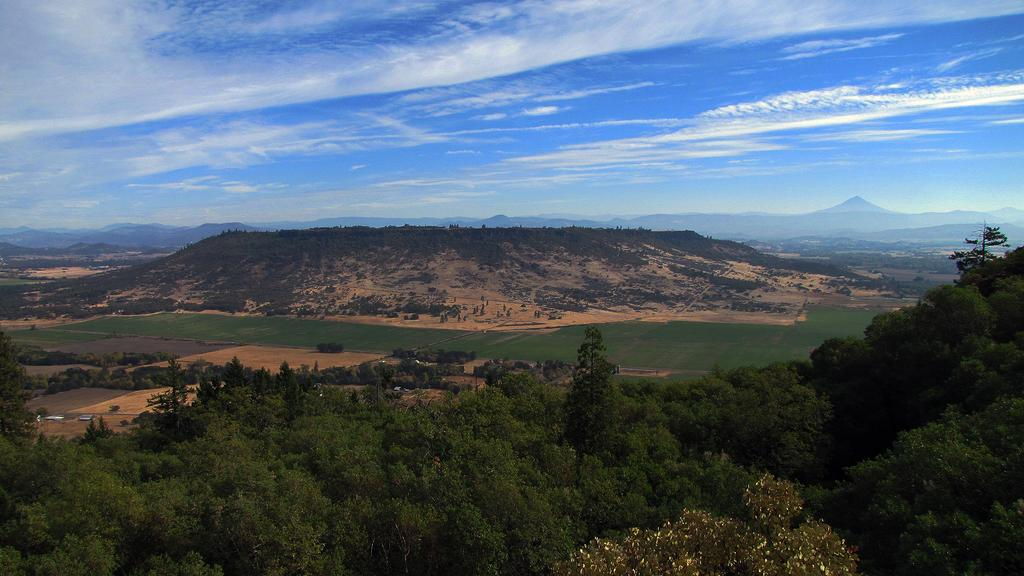What type of natural environment is depicted in the image? The image contains trees, fields, and hills, which are all part of a natural environment. Can you describe the landscape in the image? The landscape in the image includes trees, fields, and hills. What is visible in the sky in the image? The sky is visible in the image, but no specific details about the sky are provided. How many different types of natural features can be seen in the image? There are three different types of natural features in the image: trees, fields, and hills. What type of tax is being discussed in the image? There is no discussion of tax in the image; it features trees, fields, and hills in a natural landscape. 